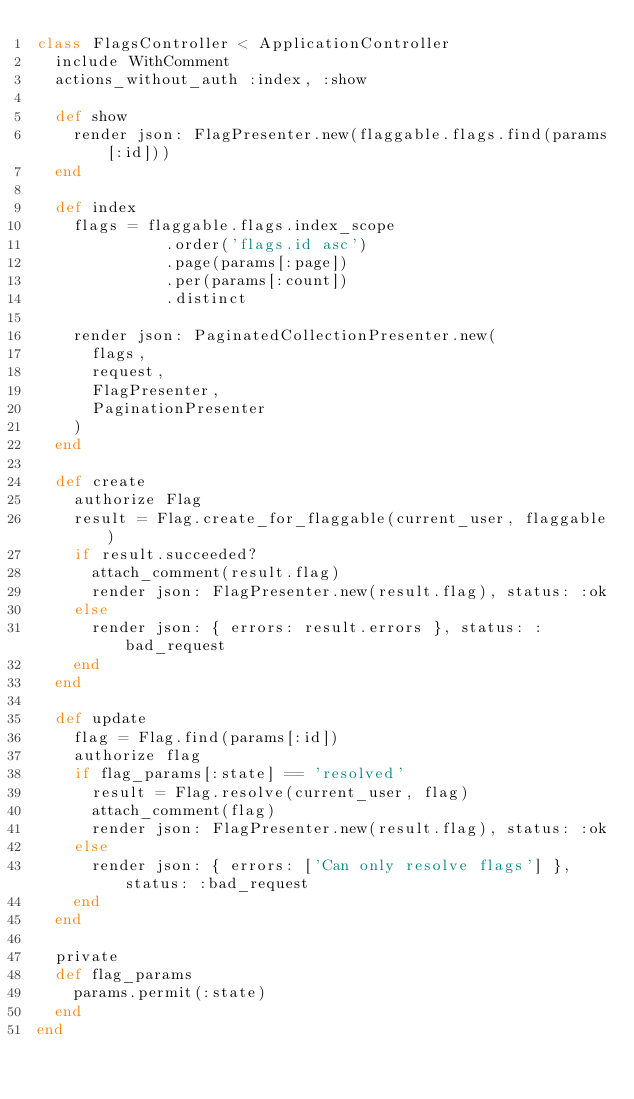Convert code to text. <code><loc_0><loc_0><loc_500><loc_500><_Ruby_>class FlagsController < ApplicationController
  include WithComment
  actions_without_auth :index, :show

  def show
    render json: FlagPresenter.new(flaggable.flags.find(params[:id]))
  end

  def index
    flags = flaggable.flags.index_scope
              .order('flags.id asc')
              .page(params[:page])
              .per(params[:count])
              .distinct

    render json: PaginatedCollectionPresenter.new(
      flags,
      request,
      FlagPresenter,
      PaginationPresenter
    )
  end

  def create
    authorize Flag
    result = Flag.create_for_flaggable(current_user, flaggable)
    if result.succeeded?
      attach_comment(result.flag)
      render json: FlagPresenter.new(result.flag), status: :ok
    else
      render json: { errors: result.errors }, status: :bad_request
    end
  end

  def update
    flag = Flag.find(params[:id])
    authorize flag
    if flag_params[:state] == 'resolved'
      result = Flag.resolve(current_user, flag)
      attach_comment(flag)
      render json: FlagPresenter.new(result.flag), status: :ok
    else
      render json: { errors: ['Can only resolve flags'] }, status: :bad_request
    end
  end

  private
  def flag_params
    params.permit(:state)
  end
end
</code> 